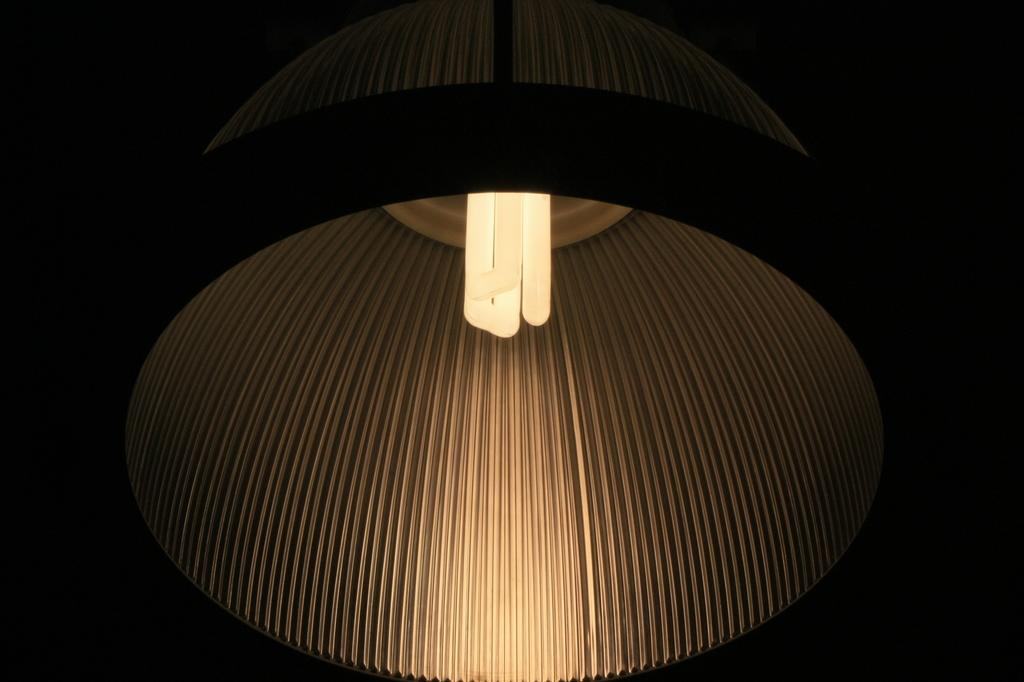What object can be seen in the image? There is a lamp in the image. What color is the lamp? The lamp is black in color. Can you recall any memories associated with the police near the lake in the image? There is no mention of a lake, police, or any memories in the image. The image only features a black lamp. 